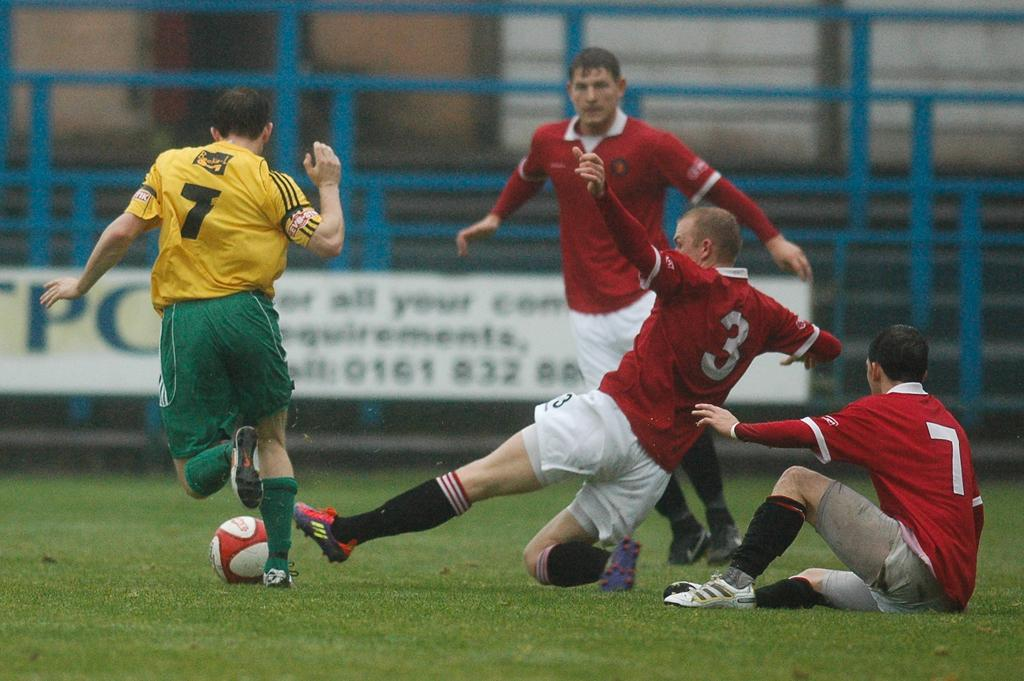<image>
Render a clear and concise summary of the photo. Two teams are playing soccer while there is a banner about full filling the requirements in the back. 